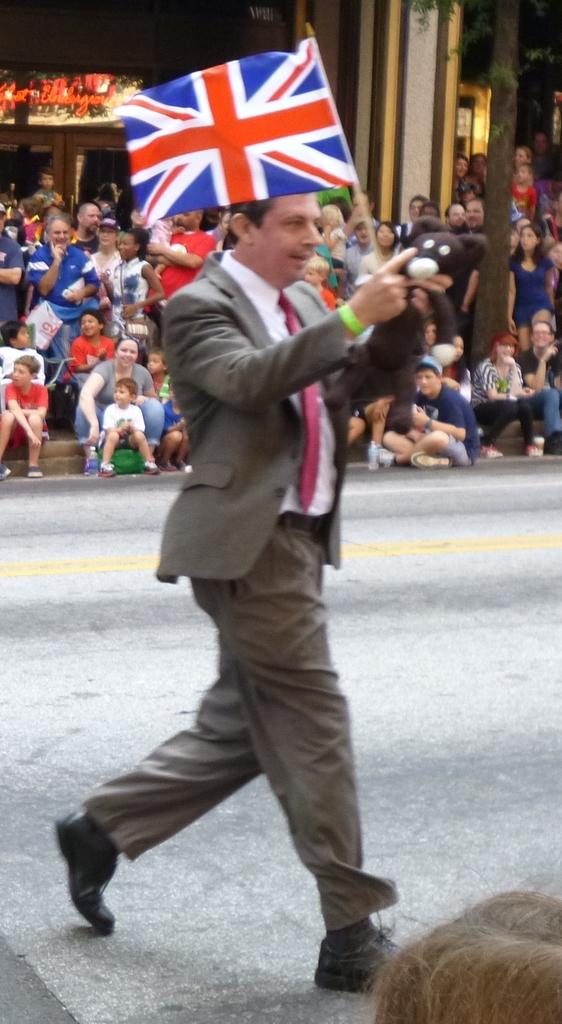Who is the main subject in the image? There is a man in the center of the image. What is the man doing in the image? The man is walking in the image. What is the man holding in the image? The man is holding a flag and a teddy bear in the image. What can be seen in the background of the image? There is a crowd and a building in the background of the image. What is the manager's reaction to the man holding a teddy bear in the image? There is no manager present in the image, so it is not possible to determine their reaction. 